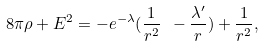Convert formula to latex. <formula><loc_0><loc_0><loc_500><loc_500>8 \pi \rho + E ^ { 2 } = - e ^ { - \lambda } ( \frac { 1 } { r ^ { 2 } } \ - \frac { { \lambda } ^ { \prime } } { r } ) + \frac { 1 } { r ^ { 2 } } ,</formula> 